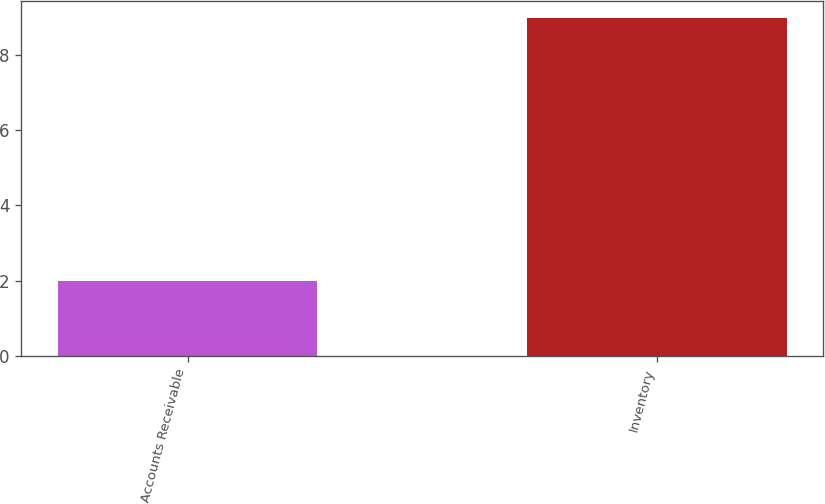Convert chart. <chart><loc_0><loc_0><loc_500><loc_500><bar_chart><fcel>Accounts Receivable<fcel>Inventory<nl><fcel>2<fcel>9<nl></chart> 